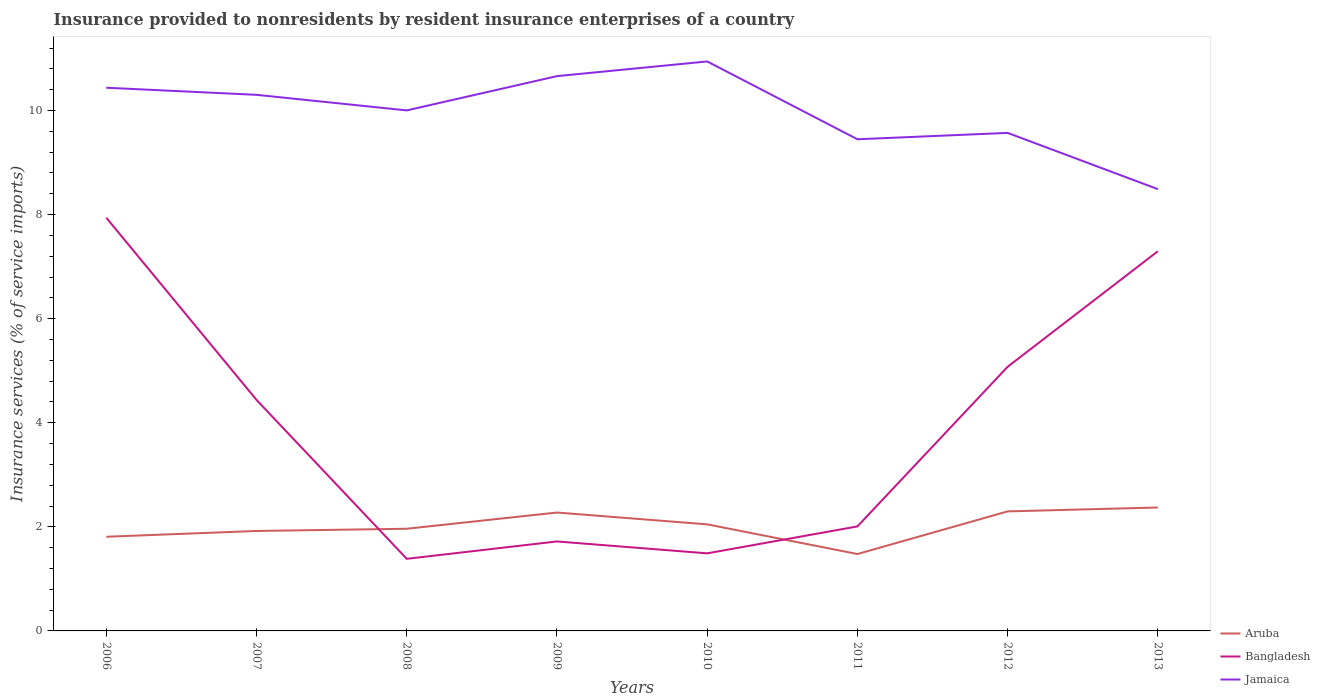Does the line corresponding to Bangladesh intersect with the line corresponding to Jamaica?
Offer a very short reply. No. Is the number of lines equal to the number of legend labels?
Offer a very short reply. Yes. Across all years, what is the maximum insurance provided to nonresidents in Jamaica?
Offer a very short reply. 8.49. In which year was the insurance provided to nonresidents in Jamaica maximum?
Offer a very short reply. 2013. What is the total insurance provided to nonresidents in Bangladesh in the graph?
Offer a very short reply. 2.43. What is the difference between the highest and the second highest insurance provided to nonresidents in Jamaica?
Your answer should be compact. 2.45. Is the insurance provided to nonresidents in Aruba strictly greater than the insurance provided to nonresidents in Jamaica over the years?
Your answer should be compact. Yes. How many years are there in the graph?
Your answer should be compact. 8. Are the values on the major ticks of Y-axis written in scientific E-notation?
Offer a very short reply. No. Does the graph contain any zero values?
Make the answer very short. No. Where does the legend appear in the graph?
Ensure brevity in your answer.  Bottom right. How are the legend labels stacked?
Your answer should be compact. Vertical. What is the title of the graph?
Provide a short and direct response. Insurance provided to nonresidents by resident insurance enterprises of a country. Does "Yemen, Rep." appear as one of the legend labels in the graph?
Your response must be concise. No. What is the label or title of the X-axis?
Your answer should be very brief. Years. What is the label or title of the Y-axis?
Your answer should be very brief. Insurance services (% of service imports). What is the Insurance services (% of service imports) in Aruba in 2006?
Keep it short and to the point. 1.81. What is the Insurance services (% of service imports) of Bangladesh in 2006?
Provide a succinct answer. 7.94. What is the Insurance services (% of service imports) of Jamaica in 2006?
Offer a very short reply. 10.44. What is the Insurance services (% of service imports) in Aruba in 2007?
Give a very brief answer. 1.92. What is the Insurance services (% of service imports) in Bangladesh in 2007?
Offer a terse response. 4.44. What is the Insurance services (% of service imports) in Jamaica in 2007?
Your answer should be compact. 10.3. What is the Insurance services (% of service imports) of Aruba in 2008?
Your answer should be very brief. 1.96. What is the Insurance services (% of service imports) of Bangladesh in 2008?
Provide a short and direct response. 1.39. What is the Insurance services (% of service imports) in Jamaica in 2008?
Keep it short and to the point. 10. What is the Insurance services (% of service imports) in Aruba in 2009?
Ensure brevity in your answer.  2.27. What is the Insurance services (% of service imports) in Bangladesh in 2009?
Your response must be concise. 1.72. What is the Insurance services (% of service imports) of Jamaica in 2009?
Provide a short and direct response. 10.66. What is the Insurance services (% of service imports) in Aruba in 2010?
Ensure brevity in your answer.  2.05. What is the Insurance services (% of service imports) of Bangladesh in 2010?
Offer a very short reply. 1.49. What is the Insurance services (% of service imports) in Jamaica in 2010?
Keep it short and to the point. 10.94. What is the Insurance services (% of service imports) of Aruba in 2011?
Offer a terse response. 1.48. What is the Insurance services (% of service imports) in Bangladesh in 2011?
Make the answer very short. 2.01. What is the Insurance services (% of service imports) of Jamaica in 2011?
Your response must be concise. 9.45. What is the Insurance services (% of service imports) of Aruba in 2012?
Give a very brief answer. 2.3. What is the Insurance services (% of service imports) in Bangladesh in 2012?
Ensure brevity in your answer.  5.08. What is the Insurance services (% of service imports) in Jamaica in 2012?
Your answer should be compact. 9.57. What is the Insurance services (% of service imports) in Aruba in 2013?
Your answer should be very brief. 2.37. What is the Insurance services (% of service imports) of Bangladesh in 2013?
Provide a succinct answer. 7.3. What is the Insurance services (% of service imports) of Jamaica in 2013?
Ensure brevity in your answer.  8.49. Across all years, what is the maximum Insurance services (% of service imports) of Aruba?
Your response must be concise. 2.37. Across all years, what is the maximum Insurance services (% of service imports) of Bangladesh?
Give a very brief answer. 7.94. Across all years, what is the maximum Insurance services (% of service imports) of Jamaica?
Your answer should be very brief. 10.94. Across all years, what is the minimum Insurance services (% of service imports) of Aruba?
Give a very brief answer. 1.48. Across all years, what is the minimum Insurance services (% of service imports) of Bangladesh?
Ensure brevity in your answer.  1.39. Across all years, what is the minimum Insurance services (% of service imports) of Jamaica?
Keep it short and to the point. 8.49. What is the total Insurance services (% of service imports) in Aruba in the graph?
Offer a terse response. 16.16. What is the total Insurance services (% of service imports) in Bangladesh in the graph?
Keep it short and to the point. 31.35. What is the total Insurance services (% of service imports) in Jamaica in the graph?
Your response must be concise. 79.85. What is the difference between the Insurance services (% of service imports) in Aruba in 2006 and that in 2007?
Keep it short and to the point. -0.11. What is the difference between the Insurance services (% of service imports) in Bangladesh in 2006 and that in 2007?
Your answer should be very brief. 3.5. What is the difference between the Insurance services (% of service imports) of Jamaica in 2006 and that in 2007?
Keep it short and to the point. 0.14. What is the difference between the Insurance services (% of service imports) in Aruba in 2006 and that in 2008?
Provide a succinct answer. -0.15. What is the difference between the Insurance services (% of service imports) of Bangladesh in 2006 and that in 2008?
Give a very brief answer. 6.55. What is the difference between the Insurance services (% of service imports) of Jamaica in 2006 and that in 2008?
Offer a terse response. 0.44. What is the difference between the Insurance services (% of service imports) of Aruba in 2006 and that in 2009?
Keep it short and to the point. -0.47. What is the difference between the Insurance services (% of service imports) in Bangladesh in 2006 and that in 2009?
Your answer should be very brief. 6.22. What is the difference between the Insurance services (% of service imports) of Jamaica in 2006 and that in 2009?
Make the answer very short. -0.22. What is the difference between the Insurance services (% of service imports) in Aruba in 2006 and that in 2010?
Offer a terse response. -0.24. What is the difference between the Insurance services (% of service imports) of Bangladesh in 2006 and that in 2010?
Make the answer very short. 6.45. What is the difference between the Insurance services (% of service imports) in Jamaica in 2006 and that in 2010?
Offer a very short reply. -0.51. What is the difference between the Insurance services (% of service imports) of Aruba in 2006 and that in 2011?
Make the answer very short. 0.33. What is the difference between the Insurance services (% of service imports) in Bangladesh in 2006 and that in 2011?
Keep it short and to the point. 5.93. What is the difference between the Insurance services (% of service imports) of Jamaica in 2006 and that in 2011?
Offer a very short reply. 0.99. What is the difference between the Insurance services (% of service imports) in Aruba in 2006 and that in 2012?
Make the answer very short. -0.49. What is the difference between the Insurance services (% of service imports) of Bangladesh in 2006 and that in 2012?
Make the answer very short. 2.86. What is the difference between the Insurance services (% of service imports) of Jamaica in 2006 and that in 2012?
Make the answer very short. 0.87. What is the difference between the Insurance services (% of service imports) in Aruba in 2006 and that in 2013?
Your answer should be very brief. -0.56. What is the difference between the Insurance services (% of service imports) in Bangladesh in 2006 and that in 2013?
Offer a very short reply. 0.64. What is the difference between the Insurance services (% of service imports) in Jamaica in 2006 and that in 2013?
Offer a terse response. 1.95. What is the difference between the Insurance services (% of service imports) of Aruba in 2007 and that in 2008?
Offer a very short reply. -0.04. What is the difference between the Insurance services (% of service imports) in Bangladesh in 2007 and that in 2008?
Ensure brevity in your answer.  3.05. What is the difference between the Insurance services (% of service imports) in Jamaica in 2007 and that in 2008?
Give a very brief answer. 0.3. What is the difference between the Insurance services (% of service imports) of Aruba in 2007 and that in 2009?
Offer a very short reply. -0.35. What is the difference between the Insurance services (% of service imports) of Bangladesh in 2007 and that in 2009?
Your answer should be compact. 2.72. What is the difference between the Insurance services (% of service imports) of Jamaica in 2007 and that in 2009?
Provide a short and direct response. -0.36. What is the difference between the Insurance services (% of service imports) of Aruba in 2007 and that in 2010?
Keep it short and to the point. -0.13. What is the difference between the Insurance services (% of service imports) in Bangladesh in 2007 and that in 2010?
Provide a short and direct response. 2.95. What is the difference between the Insurance services (% of service imports) of Jamaica in 2007 and that in 2010?
Give a very brief answer. -0.64. What is the difference between the Insurance services (% of service imports) in Aruba in 2007 and that in 2011?
Give a very brief answer. 0.44. What is the difference between the Insurance services (% of service imports) in Bangladesh in 2007 and that in 2011?
Give a very brief answer. 2.43. What is the difference between the Insurance services (% of service imports) of Jamaica in 2007 and that in 2011?
Your answer should be compact. 0.85. What is the difference between the Insurance services (% of service imports) in Aruba in 2007 and that in 2012?
Keep it short and to the point. -0.38. What is the difference between the Insurance services (% of service imports) of Bangladesh in 2007 and that in 2012?
Your answer should be compact. -0.64. What is the difference between the Insurance services (% of service imports) of Jamaica in 2007 and that in 2012?
Your answer should be very brief. 0.73. What is the difference between the Insurance services (% of service imports) of Aruba in 2007 and that in 2013?
Your answer should be compact. -0.45. What is the difference between the Insurance services (% of service imports) of Bangladesh in 2007 and that in 2013?
Make the answer very short. -2.86. What is the difference between the Insurance services (% of service imports) of Jamaica in 2007 and that in 2013?
Keep it short and to the point. 1.81. What is the difference between the Insurance services (% of service imports) of Aruba in 2008 and that in 2009?
Make the answer very short. -0.31. What is the difference between the Insurance services (% of service imports) in Bangladesh in 2008 and that in 2009?
Your answer should be very brief. -0.33. What is the difference between the Insurance services (% of service imports) in Jamaica in 2008 and that in 2009?
Provide a short and direct response. -0.66. What is the difference between the Insurance services (% of service imports) of Aruba in 2008 and that in 2010?
Your answer should be compact. -0.08. What is the difference between the Insurance services (% of service imports) of Bangladesh in 2008 and that in 2010?
Offer a very short reply. -0.1. What is the difference between the Insurance services (% of service imports) of Jamaica in 2008 and that in 2010?
Provide a short and direct response. -0.94. What is the difference between the Insurance services (% of service imports) of Aruba in 2008 and that in 2011?
Provide a short and direct response. 0.49. What is the difference between the Insurance services (% of service imports) in Bangladesh in 2008 and that in 2011?
Offer a very short reply. -0.62. What is the difference between the Insurance services (% of service imports) in Jamaica in 2008 and that in 2011?
Give a very brief answer. 0.55. What is the difference between the Insurance services (% of service imports) of Aruba in 2008 and that in 2012?
Give a very brief answer. -0.33. What is the difference between the Insurance services (% of service imports) of Bangladesh in 2008 and that in 2012?
Provide a short and direct response. -3.69. What is the difference between the Insurance services (% of service imports) of Jamaica in 2008 and that in 2012?
Give a very brief answer. 0.43. What is the difference between the Insurance services (% of service imports) of Aruba in 2008 and that in 2013?
Ensure brevity in your answer.  -0.41. What is the difference between the Insurance services (% of service imports) of Bangladesh in 2008 and that in 2013?
Your answer should be compact. -5.91. What is the difference between the Insurance services (% of service imports) in Jamaica in 2008 and that in 2013?
Provide a short and direct response. 1.51. What is the difference between the Insurance services (% of service imports) in Aruba in 2009 and that in 2010?
Make the answer very short. 0.23. What is the difference between the Insurance services (% of service imports) in Bangladesh in 2009 and that in 2010?
Give a very brief answer. 0.23. What is the difference between the Insurance services (% of service imports) of Jamaica in 2009 and that in 2010?
Your answer should be very brief. -0.28. What is the difference between the Insurance services (% of service imports) in Aruba in 2009 and that in 2011?
Provide a succinct answer. 0.8. What is the difference between the Insurance services (% of service imports) in Bangladesh in 2009 and that in 2011?
Your answer should be compact. -0.29. What is the difference between the Insurance services (% of service imports) of Jamaica in 2009 and that in 2011?
Provide a succinct answer. 1.21. What is the difference between the Insurance services (% of service imports) in Aruba in 2009 and that in 2012?
Keep it short and to the point. -0.02. What is the difference between the Insurance services (% of service imports) in Bangladesh in 2009 and that in 2012?
Your answer should be compact. -3.36. What is the difference between the Insurance services (% of service imports) in Jamaica in 2009 and that in 2012?
Provide a short and direct response. 1.09. What is the difference between the Insurance services (% of service imports) of Aruba in 2009 and that in 2013?
Ensure brevity in your answer.  -0.1. What is the difference between the Insurance services (% of service imports) in Bangladesh in 2009 and that in 2013?
Provide a succinct answer. -5.58. What is the difference between the Insurance services (% of service imports) in Jamaica in 2009 and that in 2013?
Give a very brief answer. 2.17. What is the difference between the Insurance services (% of service imports) in Aruba in 2010 and that in 2011?
Give a very brief answer. 0.57. What is the difference between the Insurance services (% of service imports) in Bangladesh in 2010 and that in 2011?
Your answer should be compact. -0.52. What is the difference between the Insurance services (% of service imports) in Jamaica in 2010 and that in 2011?
Offer a very short reply. 1.5. What is the difference between the Insurance services (% of service imports) of Aruba in 2010 and that in 2012?
Offer a terse response. -0.25. What is the difference between the Insurance services (% of service imports) in Bangladesh in 2010 and that in 2012?
Offer a terse response. -3.59. What is the difference between the Insurance services (% of service imports) in Jamaica in 2010 and that in 2012?
Ensure brevity in your answer.  1.37. What is the difference between the Insurance services (% of service imports) in Aruba in 2010 and that in 2013?
Your answer should be very brief. -0.32. What is the difference between the Insurance services (% of service imports) in Bangladesh in 2010 and that in 2013?
Provide a short and direct response. -5.81. What is the difference between the Insurance services (% of service imports) in Jamaica in 2010 and that in 2013?
Offer a very short reply. 2.45. What is the difference between the Insurance services (% of service imports) in Aruba in 2011 and that in 2012?
Your answer should be very brief. -0.82. What is the difference between the Insurance services (% of service imports) in Bangladesh in 2011 and that in 2012?
Ensure brevity in your answer.  -3.07. What is the difference between the Insurance services (% of service imports) in Jamaica in 2011 and that in 2012?
Ensure brevity in your answer.  -0.12. What is the difference between the Insurance services (% of service imports) in Aruba in 2011 and that in 2013?
Provide a succinct answer. -0.89. What is the difference between the Insurance services (% of service imports) of Bangladesh in 2011 and that in 2013?
Make the answer very short. -5.29. What is the difference between the Insurance services (% of service imports) in Jamaica in 2011 and that in 2013?
Provide a short and direct response. 0.96. What is the difference between the Insurance services (% of service imports) in Aruba in 2012 and that in 2013?
Your response must be concise. -0.08. What is the difference between the Insurance services (% of service imports) in Bangladesh in 2012 and that in 2013?
Provide a succinct answer. -2.22. What is the difference between the Insurance services (% of service imports) in Jamaica in 2012 and that in 2013?
Provide a short and direct response. 1.08. What is the difference between the Insurance services (% of service imports) of Aruba in 2006 and the Insurance services (% of service imports) of Bangladesh in 2007?
Make the answer very short. -2.63. What is the difference between the Insurance services (% of service imports) of Aruba in 2006 and the Insurance services (% of service imports) of Jamaica in 2007?
Make the answer very short. -8.49. What is the difference between the Insurance services (% of service imports) in Bangladesh in 2006 and the Insurance services (% of service imports) in Jamaica in 2007?
Give a very brief answer. -2.36. What is the difference between the Insurance services (% of service imports) in Aruba in 2006 and the Insurance services (% of service imports) in Bangladesh in 2008?
Keep it short and to the point. 0.42. What is the difference between the Insurance services (% of service imports) in Aruba in 2006 and the Insurance services (% of service imports) in Jamaica in 2008?
Give a very brief answer. -8.19. What is the difference between the Insurance services (% of service imports) in Bangladesh in 2006 and the Insurance services (% of service imports) in Jamaica in 2008?
Provide a short and direct response. -2.06. What is the difference between the Insurance services (% of service imports) in Aruba in 2006 and the Insurance services (% of service imports) in Bangladesh in 2009?
Give a very brief answer. 0.09. What is the difference between the Insurance services (% of service imports) of Aruba in 2006 and the Insurance services (% of service imports) of Jamaica in 2009?
Keep it short and to the point. -8.85. What is the difference between the Insurance services (% of service imports) of Bangladesh in 2006 and the Insurance services (% of service imports) of Jamaica in 2009?
Give a very brief answer. -2.72. What is the difference between the Insurance services (% of service imports) in Aruba in 2006 and the Insurance services (% of service imports) in Bangladesh in 2010?
Ensure brevity in your answer.  0.32. What is the difference between the Insurance services (% of service imports) of Aruba in 2006 and the Insurance services (% of service imports) of Jamaica in 2010?
Make the answer very short. -9.13. What is the difference between the Insurance services (% of service imports) of Bangladesh in 2006 and the Insurance services (% of service imports) of Jamaica in 2010?
Keep it short and to the point. -3. What is the difference between the Insurance services (% of service imports) of Aruba in 2006 and the Insurance services (% of service imports) of Bangladesh in 2011?
Give a very brief answer. -0.2. What is the difference between the Insurance services (% of service imports) of Aruba in 2006 and the Insurance services (% of service imports) of Jamaica in 2011?
Ensure brevity in your answer.  -7.64. What is the difference between the Insurance services (% of service imports) in Bangladesh in 2006 and the Insurance services (% of service imports) in Jamaica in 2011?
Make the answer very short. -1.51. What is the difference between the Insurance services (% of service imports) of Aruba in 2006 and the Insurance services (% of service imports) of Bangladesh in 2012?
Your answer should be compact. -3.27. What is the difference between the Insurance services (% of service imports) in Aruba in 2006 and the Insurance services (% of service imports) in Jamaica in 2012?
Ensure brevity in your answer.  -7.76. What is the difference between the Insurance services (% of service imports) of Bangladesh in 2006 and the Insurance services (% of service imports) of Jamaica in 2012?
Ensure brevity in your answer.  -1.63. What is the difference between the Insurance services (% of service imports) of Aruba in 2006 and the Insurance services (% of service imports) of Bangladesh in 2013?
Your answer should be very brief. -5.49. What is the difference between the Insurance services (% of service imports) of Aruba in 2006 and the Insurance services (% of service imports) of Jamaica in 2013?
Provide a short and direct response. -6.68. What is the difference between the Insurance services (% of service imports) of Bangladesh in 2006 and the Insurance services (% of service imports) of Jamaica in 2013?
Your response must be concise. -0.55. What is the difference between the Insurance services (% of service imports) in Aruba in 2007 and the Insurance services (% of service imports) in Bangladesh in 2008?
Offer a terse response. 0.53. What is the difference between the Insurance services (% of service imports) of Aruba in 2007 and the Insurance services (% of service imports) of Jamaica in 2008?
Your answer should be compact. -8.08. What is the difference between the Insurance services (% of service imports) of Bangladesh in 2007 and the Insurance services (% of service imports) of Jamaica in 2008?
Give a very brief answer. -5.56. What is the difference between the Insurance services (% of service imports) of Aruba in 2007 and the Insurance services (% of service imports) of Bangladesh in 2009?
Your answer should be very brief. 0.2. What is the difference between the Insurance services (% of service imports) of Aruba in 2007 and the Insurance services (% of service imports) of Jamaica in 2009?
Provide a short and direct response. -8.74. What is the difference between the Insurance services (% of service imports) of Bangladesh in 2007 and the Insurance services (% of service imports) of Jamaica in 2009?
Offer a very short reply. -6.22. What is the difference between the Insurance services (% of service imports) of Aruba in 2007 and the Insurance services (% of service imports) of Bangladesh in 2010?
Provide a succinct answer. 0.43. What is the difference between the Insurance services (% of service imports) of Aruba in 2007 and the Insurance services (% of service imports) of Jamaica in 2010?
Ensure brevity in your answer.  -9.02. What is the difference between the Insurance services (% of service imports) of Bangladesh in 2007 and the Insurance services (% of service imports) of Jamaica in 2010?
Your answer should be very brief. -6.5. What is the difference between the Insurance services (% of service imports) in Aruba in 2007 and the Insurance services (% of service imports) in Bangladesh in 2011?
Offer a terse response. -0.09. What is the difference between the Insurance services (% of service imports) in Aruba in 2007 and the Insurance services (% of service imports) in Jamaica in 2011?
Keep it short and to the point. -7.53. What is the difference between the Insurance services (% of service imports) of Bangladesh in 2007 and the Insurance services (% of service imports) of Jamaica in 2011?
Your response must be concise. -5.01. What is the difference between the Insurance services (% of service imports) of Aruba in 2007 and the Insurance services (% of service imports) of Bangladesh in 2012?
Ensure brevity in your answer.  -3.16. What is the difference between the Insurance services (% of service imports) in Aruba in 2007 and the Insurance services (% of service imports) in Jamaica in 2012?
Your answer should be compact. -7.65. What is the difference between the Insurance services (% of service imports) of Bangladesh in 2007 and the Insurance services (% of service imports) of Jamaica in 2012?
Provide a succinct answer. -5.13. What is the difference between the Insurance services (% of service imports) in Aruba in 2007 and the Insurance services (% of service imports) in Bangladesh in 2013?
Provide a short and direct response. -5.38. What is the difference between the Insurance services (% of service imports) of Aruba in 2007 and the Insurance services (% of service imports) of Jamaica in 2013?
Your answer should be very brief. -6.57. What is the difference between the Insurance services (% of service imports) in Bangladesh in 2007 and the Insurance services (% of service imports) in Jamaica in 2013?
Provide a short and direct response. -4.05. What is the difference between the Insurance services (% of service imports) in Aruba in 2008 and the Insurance services (% of service imports) in Bangladesh in 2009?
Make the answer very short. 0.24. What is the difference between the Insurance services (% of service imports) in Aruba in 2008 and the Insurance services (% of service imports) in Jamaica in 2009?
Ensure brevity in your answer.  -8.7. What is the difference between the Insurance services (% of service imports) in Bangladesh in 2008 and the Insurance services (% of service imports) in Jamaica in 2009?
Provide a succinct answer. -9.27. What is the difference between the Insurance services (% of service imports) in Aruba in 2008 and the Insurance services (% of service imports) in Bangladesh in 2010?
Ensure brevity in your answer.  0.47. What is the difference between the Insurance services (% of service imports) of Aruba in 2008 and the Insurance services (% of service imports) of Jamaica in 2010?
Give a very brief answer. -8.98. What is the difference between the Insurance services (% of service imports) of Bangladesh in 2008 and the Insurance services (% of service imports) of Jamaica in 2010?
Offer a terse response. -9.56. What is the difference between the Insurance services (% of service imports) in Aruba in 2008 and the Insurance services (% of service imports) in Bangladesh in 2011?
Your answer should be very brief. -0.04. What is the difference between the Insurance services (% of service imports) of Aruba in 2008 and the Insurance services (% of service imports) of Jamaica in 2011?
Your answer should be very brief. -7.48. What is the difference between the Insurance services (% of service imports) of Bangladesh in 2008 and the Insurance services (% of service imports) of Jamaica in 2011?
Ensure brevity in your answer.  -8.06. What is the difference between the Insurance services (% of service imports) of Aruba in 2008 and the Insurance services (% of service imports) of Bangladesh in 2012?
Keep it short and to the point. -3.11. What is the difference between the Insurance services (% of service imports) of Aruba in 2008 and the Insurance services (% of service imports) of Jamaica in 2012?
Provide a short and direct response. -7.61. What is the difference between the Insurance services (% of service imports) of Bangladesh in 2008 and the Insurance services (% of service imports) of Jamaica in 2012?
Give a very brief answer. -8.18. What is the difference between the Insurance services (% of service imports) of Aruba in 2008 and the Insurance services (% of service imports) of Bangladesh in 2013?
Offer a terse response. -5.33. What is the difference between the Insurance services (% of service imports) in Aruba in 2008 and the Insurance services (% of service imports) in Jamaica in 2013?
Give a very brief answer. -6.52. What is the difference between the Insurance services (% of service imports) in Bangladesh in 2008 and the Insurance services (% of service imports) in Jamaica in 2013?
Offer a terse response. -7.1. What is the difference between the Insurance services (% of service imports) of Aruba in 2009 and the Insurance services (% of service imports) of Bangladesh in 2010?
Give a very brief answer. 0.78. What is the difference between the Insurance services (% of service imports) of Aruba in 2009 and the Insurance services (% of service imports) of Jamaica in 2010?
Keep it short and to the point. -8.67. What is the difference between the Insurance services (% of service imports) in Bangladesh in 2009 and the Insurance services (% of service imports) in Jamaica in 2010?
Your answer should be compact. -9.22. What is the difference between the Insurance services (% of service imports) of Aruba in 2009 and the Insurance services (% of service imports) of Bangladesh in 2011?
Your answer should be compact. 0.27. What is the difference between the Insurance services (% of service imports) in Aruba in 2009 and the Insurance services (% of service imports) in Jamaica in 2011?
Your answer should be compact. -7.17. What is the difference between the Insurance services (% of service imports) in Bangladesh in 2009 and the Insurance services (% of service imports) in Jamaica in 2011?
Offer a terse response. -7.73. What is the difference between the Insurance services (% of service imports) in Aruba in 2009 and the Insurance services (% of service imports) in Bangladesh in 2012?
Your response must be concise. -2.8. What is the difference between the Insurance services (% of service imports) of Aruba in 2009 and the Insurance services (% of service imports) of Jamaica in 2012?
Offer a very short reply. -7.29. What is the difference between the Insurance services (% of service imports) in Bangladesh in 2009 and the Insurance services (% of service imports) in Jamaica in 2012?
Your response must be concise. -7.85. What is the difference between the Insurance services (% of service imports) of Aruba in 2009 and the Insurance services (% of service imports) of Bangladesh in 2013?
Offer a very short reply. -5.02. What is the difference between the Insurance services (% of service imports) in Aruba in 2009 and the Insurance services (% of service imports) in Jamaica in 2013?
Your answer should be compact. -6.21. What is the difference between the Insurance services (% of service imports) in Bangladesh in 2009 and the Insurance services (% of service imports) in Jamaica in 2013?
Offer a very short reply. -6.77. What is the difference between the Insurance services (% of service imports) of Aruba in 2010 and the Insurance services (% of service imports) of Bangladesh in 2011?
Your answer should be compact. 0.04. What is the difference between the Insurance services (% of service imports) of Aruba in 2010 and the Insurance services (% of service imports) of Jamaica in 2011?
Keep it short and to the point. -7.4. What is the difference between the Insurance services (% of service imports) of Bangladesh in 2010 and the Insurance services (% of service imports) of Jamaica in 2011?
Provide a short and direct response. -7.96. What is the difference between the Insurance services (% of service imports) of Aruba in 2010 and the Insurance services (% of service imports) of Bangladesh in 2012?
Provide a short and direct response. -3.03. What is the difference between the Insurance services (% of service imports) in Aruba in 2010 and the Insurance services (% of service imports) in Jamaica in 2012?
Keep it short and to the point. -7.52. What is the difference between the Insurance services (% of service imports) in Bangladesh in 2010 and the Insurance services (% of service imports) in Jamaica in 2012?
Your answer should be compact. -8.08. What is the difference between the Insurance services (% of service imports) in Aruba in 2010 and the Insurance services (% of service imports) in Bangladesh in 2013?
Your answer should be compact. -5.25. What is the difference between the Insurance services (% of service imports) in Aruba in 2010 and the Insurance services (% of service imports) in Jamaica in 2013?
Your response must be concise. -6.44. What is the difference between the Insurance services (% of service imports) of Bangladesh in 2010 and the Insurance services (% of service imports) of Jamaica in 2013?
Give a very brief answer. -7. What is the difference between the Insurance services (% of service imports) of Aruba in 2011 and the Insurance services (% of service imports) of Bangladesh in 2012?
Provide a succinct answer. -3.6. What is the difference between the Insurance services (% of service imports) in Aruba in 2011 and the Insurance services (% of service imports) in Jamaica in 2012?
Offer a very short reply. -8.09. What is the difference between the Insurance services (% of service imports) in Bangladesh in 2011 and the Insurance services (% of service imports) in Jamaica in 2012?
Offer a terse response. -7.56. What is the difference between the Insurance services (% of service imports) of Aruba in 2011 and the Insurance services (% of service imports) of Bangladesh in 2013?
Your response must be concise. -5.82. What is the difference between the Insurance services (% of service imports) of Aruba in 2011 and the Insurance services (% of service imports) of Jamaica in 2013?
Provide a succinct answer. -7.01. What is the difference between the Insurance services (% of service imports) of Bangladesh in 2011 and the Insurance services (% of service imports) of Jamaica in 2013?
Your answer should be compact. -6.48. What is the difference between the Insurance services (% of service imports) of Aruba in 2012 and the Insurance services (% of service imports) of Bangladesh in 2013?
Provide a succinct answer. -5. What is the difference between the Insurance services (% of service imports) of Aruba in 2012 and the Insurance services (% of service imports) of Jamaica in 2013?
Make the answer very short. -6.19. What is the difference between the Insurance services (% of service imports) of Bangladesh in 2012 and the Insurance services (% of service imports) of Jamaica in 2013?
Make the answer very short. -3.41. What is the average Insurance services (% of service imports) in Aruba per year?
Ensure brevity in your answer.  2.02. What is the average Insurance services (% of service imports) of Bangladesh per year?
Provide a short and direct response. 3.92. What is the average Insurance services (% of service imports) in Jamaica per year?
Your response must be concise. 9.98. In the year 2006, what is the difference between the Insurance services (% of service imports) in Aruba and Insurance services (% of service imports) in Bangladesh?
Your answer should be compact. -6.13. In the year 2006, what is the difference between the Insurance services (% of service imports) of Aruba and Insurance services (% of service imports) of Jamaica?
Give a very brief answer. -8.63. In the year 2006, what is the difference between the Insurance services (% of service imports) of Bangladesh and Insurance services (% of service imports) of Jamaica?
Offer a terse response. -2.5. In the year 2007, what is the difference between the Insurance services (% of service imports) in Aruba and Insurance services (% of service imports) in Bangladesh?
Offer a terse response. -2.52. In the year 2007, what is the difference between the Insurance services (% of service imports) in Aruba and Insurance services (% of service imports) in Jamaica?
Offer a terse response. -8.38. In the year 2007, what is the difference between the Insurance services (% of service imports) in Bangladesh and Insurance services (% of service imports) in Jamaica?
Offer a terse response. -5.86. In the year 2008, what is the difference between the Insurance services (% of service imports) of Aruba and Insurance services (% of service imports) of Bangladesh?
Offer a terse response. 0.58. In the year 2008, what is the difference between the Insurance services (% of service imports) of Aruba and Insurance services (% of service imports) of Jamaica?
Offer a very short reply. -8.04. In the year 2008, what is the difference between the Insurance services (% of service imports) of Bangladesh and Insurance services (% of service imports) of Jamaica?
Offer a terse response. -8.62. In the year 2009, what is the difference between the Insurance services (% of service imports) of Aruba and Insurance services (% of service imports) of Bangladesh?
Offer a very short reply. 0.56. In the year 2009, what is the difference between the Insurance services (% of service imports) in Aruba and Insurance services (% of service imports) in Jamaica?
Your response must be concise. -8.39. In the year 2009, what is the difference between the Insurance services (% of service imports) in Bangladesh and Insurance services (% of service imports) in Jamaica?
Provide a short and direct response. -8.94. In the year 2010, what is the difference between the Insurance services (% of service imports) in Aruba and Insurance services (% of service imports) in Bangladesh?
Your answer should be very brief. 0.56. In the year 2010, what is the difference between the Insurance services (% of service imports) of Aruba and Insurance services (% of service imports) of Jamaica?
Give a very brief answer. -8.89. In the year 2010, what is the difference between the Insurance services (% of service imports) of Bangladesh and Insurance services (% of service imports) of Jamaica?
Give a very brief answer. -9.45. In the year 2011, what is the difference between the Insurance services (% of service imports) in Aruba and Insurance services (% of service imports) in Bangladesh?
Your answer should be compact. -0.53. In the year 2011, what is the difference between the Insurance services (% of service imports) of Aruba and Insurance services (% of service imports) of Jamaica?
Make the answer very short. -7.97. In the year 2011, what is the difference between the Insurance services (% of service imports) in Bangladesh and Insurance services (% of service imports) in Jamaica?
Your answer should be compact. -7.44. In the year 2012, what is the difference between the Insurance services (% of service imports) of Aruba and Insurance services (% of service imports) of Bangladesh?
Give a very brief answer. -2.78. In the year 2012, what is the difference between the Insurance services (% of service imports) of Aruba and Insurance services (% of service imports) of Jamaica?
Your answer should be compact. -7.27. In the year 2012, what is the difference between the Insurance services (% of service imports) in Bangladesh and Insurance services (% of service imports) in Jamaica?
Offer a terse response. -4.49. In the year 2013, what is the difference between the Insurance services (% of service imports) in Aruba and Insurance services (% of service imports) in Bangladesh?
Give a very brief answer. -4.92. In the year 2013, what is the difference between the Insurance services (% of service imports) in Aruba and Insurance services (% of service imports) in Jamaica?
Provide a short and direct response. -6.12. In the year 2013, what is the difference between the Insurance services (% of service imports) in Bangladesh and Insurance services (% of service imports) in Jamaica?
Offer a terse response. -1.19. What is the ratio of the Insurance services (% of service imports) in Aruba in 2006 to that in 2007?
Provide a succinct answer. 0.94. What is the ratio of the Insurance services (% of service imports) in Bangladesh in 2006 to that in 2007?
Your response must be concise. 1.79. What is the ratio of the Insurance services (% of service imports) in Jamaica in 2006 to that in 2007?
Provide a succinct answer. 1.01. What is the ratio of the Insurance services (% of service imports) in Aruba in 2006 to that in 2008?
Your answer should be very brief. 0.92. What is the ratio of the Insurance services (% of service imports) of Bangladesh in 2006 to that in 2008?
Your answer should be very brief. 5.73. What is the ratio of the Insurance services (% of service imports) of Jamaica in 2006 to that in 2008?
Your response must be concise. 1.04. What is the ratio of the Insurance services (% of service imports) of Aruba in 2006 to that in 2009?
Offer a terse response. 0.8. What is the ratio of the Insurance services (% of service imports) in Bangladesh in 2006 to that in 2009?
Give a very brief answer. 4.62. What is the ratio of the Insurance services (% of service imports) of Jamaica in 2006 to that in 2009?
Your answer should be very brief. 0.98. What is the ratio of the Insurance services (% of service imports) of Aruba in 2006 to that in 2010?
Provide a short and direct response. 0.88. What is the ratio of the Insurance services (% of service imports) in Bangladesh in 2006 to that in 2010?
Provide a short and direct response. 5.33. What is the ratio of the Insurance services (% of service imports) in Jamaica in 2006 to that in 2010?
Make the answer very short. 0.95. What is the ratio of the Insurance services (% of service imports) in Aruba in 2006 to that in 2011?
Provide a succinct answer. 1.22. What is the ratio of the Insurance services (% of service imports) of Bangladesh in 2006 to that in 2011?
Keep it short and to the point. 3.95. What is the ratio of the Insurance services (% of service imports) of Jamaica in 2006 to that in 2011?
Give a very brief answer. 1.1. What is the ratio of the Insurance services (% of service imports) of Aruba in 2006 to that in 2012?
Offer a terse response. 0.79. What is the ratio of the Insurance services (% of service imports) of Bangladesh in 2006 to that in 2012?
Offer a terse response. 1.56. What is the ratio of the Insurance services (% of service imports) of Jamaica in 2006 to that in 2012?
Provide a succinct answer. 1.09. What is the ratio of the Insurance services (% of service imports) of Aruba in 2006 to that in 2013?
Offer a terse response. 0.76. What is the ratio of the Insurance services (% of service imports) of Bangladesh in 2006 to that in 2013?
Provide a short and direct response. 1.09. What is the ratio of the Insurance services (% of service imports) of Jamaica in 2006 to that in 2013?
Offer a terse response. 1.23. What is the ratio of the Insurance services (% of service imports) in Aruba in 2007 to that in 2008?
Make the answer very short. 0.98. What is the ratio of the Insurance services (% of service imports) of Bangladesh in 2007 to that in 2008?
Offer a very short reply. 3.2. What is the ratio of the Insurance services (% of service imports) of Jamaica in 2007 to that in 2008?
Give a very brief answer. 1.03. What is the ratio of the Insurance services (% of service imports) in Aruba in 2007 to that in 2009?
Ensure brevity in your answer.  0.84. What is the ratio of the Insurance services (% of service imports) of Bangladesh in 2007 to that in 2009?
Provide a short and direct response. 2.58. What is the ratio of the Insurance services (% of service imports) in Jamaica in 2007 to that in 2009?
Your answer should be very brief. 0.97. What is the ratio of the Insurance services (% of service imports) of Aruba in 2007 to that in 2010?
Make the answer very short. 0.94. What is the ratio of the Insurance services (% of service imports) of Bangladesh in 2007 to that in 2010?
Give a very brief answer. 2.98. What is the ratio of the Insurance services (% of service imports) in Jamaica in 2007 to that in 2010?
Give a very brief answer. 0.94. What is the ratio of the Insurance services (% of service imports) of Aruba in 2007 to that in 2011?
Keep it short and to the point. 1.3. What is the ratio of the Insurance services (% of service imports) in Bangladesh in 2007 to that in 2011?
Keep it short and to the point. 2.21. What is the ratio of the Insurance services (% of service imports) in Jamaica in 2007 to that in 2011?
Offer a terse response. 1.09. What is the ratio of the Insurance services (% of service imports) of Aruba in 2007 to that in 2012?
Provide a succinct answer. 0.84. What is the ratio of the Insurance services (% of service imports) of Bangladesh in 2007 to that in 2012?
Your answer should be compact. 0.87. What is the ratio of the Insurance services (% of service imports) in Jamaica in 2007 to that in 2012?
Ensure brevity in your answer.  1.08. What is the ratio of the Insurance services (% of service imports) in Aruba in 2007 to that in 2013?
Offer a very short reply. 0.81. What is the ratio of the Insurance services (% of service imports) in Bangladesh in 2007 to that in 2013?
Your answer should be very brief. 0.61. What is the ratio of the Insurance services (% of service imports) of Jamaica in 2007 to that in 2013?
Offer a terse response. 1.21. What is the ratio of the Insurance services (% of service imports) of Aruba in 2008 to that in 2009?
Offer a very short reply. 0.86. What is the ratio of the Insurance services (% of service imports) in Bangladesh in 2008 to that in 2009?
Keep it short and to the point. 0.81. What is the ratio of the Insurance services (% of service imports) in Jamaica in 2008 to that in 2009?
Keep it short and to the point. 0.94. What is the ratio of the Insurance services (% of service imports) in Aruba in 2008 to that in 2010?
Offer a terse response. 0.96. What is the ratio of the Insurance services (% of service imports) of Bangladesh in 2008 to that in 2010?
Your answer should be very brief. 0.93. What is the ratio of the Insurance services (% of service imports) of Jamaica in 2008 to that in 2010?
Give a very brief answer. 0.91. What is the ratio of the Insurance services (% of service imports) in Aruba in 2008 to that in 2011?
Your answer should be very brief. 1.33. What is the ratio of the Insurance services (% of service imports) in Bangladesh in 2008 to that in 2011?
Offer a very short reply. 0.69. What is the ratio of the Insurance services (% of service imports) in Jamaica in 2008 to that in 2011?
Your answer should be compact. 1.06. What is the ratio of the Insurance services (% of service imports) in Aruba in 2008 to that in 2012?
Make the answer very short. 0.85. What is the ratio of the Insurance services (% of service imports) of Bangladesh in 2008 to that in 2012?
Keep it short and to the point. 0.27. What is the ratio of the Insurance services (% of service imports) of Jamaica in 2008 to that in 2012?
Your answer should be compact. 1.05. What is the ratio of the Insurance services (% of service imports) in Aruba in 2008 to that in 2013?
Offer a terse response. 0.83. What is the ratio of the Insurance services (% of service imports) in Bangladesh in 2008 to that in 2013?
Make the answer very short. 0.19. What is the ratio of the Insurance services (% of service imports) of Jamaica in 2008 to that in 2013?
Your response must be concise. 1.18. What is the ratio of the Insurance services (% of service imports) of Aruba in 2009 to that in 2010?
Give a very brief answer. 1.11. What is the ratio of the Insurance services (% of service imports) of Bangladesh in 2009 to that in 2010?
Your answer should be compact. 1.15. What is the ratio of the Insurance services (% of service imports) in Jamaica in 2009 to that in 2010?
Your answer should be very brief. 0.97. What is the ratio of the Insurance services (% of service imports) in Aruba in 2009 to that in 2011?
Give a very brief answer. 1.54. What is the ratio of the Insurance services (% of service imports) in Bangladesh in 2009 to that in 2011?
Keep it short and to the point. 0.86. What is the ratio of the Insurance services (% of service imports) in Jamaica in 2009 to that in 2011?
Your response must be concise. 1.13. What is the ratio of the Insurance services (% of service imports) in Aruba in 2009 to that in 2012?
Provide a succinct answer. 0.99. What is the ratio of the Insurance services (% of service imports) in Bangladesh in 2009 to that in 2012?
Ensure brevity in your answer.  0.34. What is the ratio of the Insurance services (% of service imports) of Jamaica in 2009 to that in 2012?
Offer a terse response. 1.11. What is the ratio of the Insurance services (% of service imports) of Aruba in 2009 to that in 2013?
Your answer should be very brief. 0.96. What is the ratio of the Insurance services (% of service imports) of Bangladesh in 2009 to that in 2013?
Offer a very short reply. 0.24. What is the ratio of the Insurance services (% of service imports) in Jamaica in 2009 to that in 2013?
Offer a terse response. 1.26. What is the ratio of the Insurance services (% of service imports) of Aruba in 2010 to that in 2011?
Offer a very short reply. 1.39. What is the ratio of the Insurance services (% of service imports) in Bangladesh in 2010 to that in 2011?
Ensure brevity in your answer.  0.74. What is the ratio of the Insurance services (% of service imports) in Jamaica in 2010 to that in 2011?
Keep it short and to the point. 1.16. What is the ratio of the Insurance services (% of service imports) in Aruba in 2010 to that in 2012?
Offer a very short reply. 0.89. What is the ratio of the Insurance services (% of service imports) of Bangladesh in 2010 to that in 2012?
Offer a terse response. 0.29. What is the ratio of the Insurance services (% of service imports) of Jamaica in 2010 to that in 2012?
Provide a succinct answer. 1.14. What is the ratio of the Insurance services (% of service imports) in Aruba in 2010 to that in 2013?
Offer a terse response. 0.86. What is the ratio of the Insurance services (% of service imports) of Bangladesh in 2010 to that in 2013?
Your response must be concise. 0.2. What is the ratio of the Insurance services (% of service imports) of Jamaica in 2010 to that in 2013?
Provide a succinct answer. 1.29. What is the ratio of the Insurance services (% of service imports) of Aruba in 2011 to that in 2012?
Provide a short and direct response. 0.64. What is the ratio of the Insurance services (% of service imports) in Bangladesh in 2011 to that in 2012?
Offer a terse response. 0.4. What is the ratio of the Insurance services (% of service imports) in Jamaica in 2011 to that in 2012?
Give a very brief answer. 0.99. What is the ratio of the Insurance services (% of service imports) of Aruba in 2011 to that in 2013?
Make the answer very short. 0.62. What is the ratio of the Insurance services (% of service imports) of Bangladesh in 2011 to that in 2013?
Provide a short and direct response. 0.28. What is the ratio of the Insurance services (% of service imports) in Jamaica in 2011 to that in 2013?
Your answer should be compact. 1.11. What is the ratio of the Insurance services (% of service imports) of Aruba in 2012 to that in 2013?
Provide a succinct answer. 0.97. What is the ratio of the Insurance services (% of service imports) of Bangladesh in 2012 to that in 2013?
Your answer should be compact. 0.7. What is the ratio of the Insurance services (% of service imports) in Jamaica in 2012 to that in 2013?
Keep it short and to the point. 1.13. What is the difference between the highest and the second highest Insurance services (% of service imports) in Aruba?
Your answer should be compact. 0.08. What is the difference between the highest and the second highest Insurance services (% of service imports) of Bangladesh?
Keep it short and to the point. 0.64. What is the difference between the highest and the second highest Insurance services (% of service imports) in Jamaica?
Give a very brief answer. 0.28. What is the difference between the highest and the lowest Insurance services (% of service imports) in Aruba?
Your response must be concise. 0.89. What is the difference between the highest and the lowest Insurance services (% of service imports) in Bangladesh?
Offer a terse response. 6.55. What is the difference between the highest and the lowest Insurance services (% of service imports) of Jamaica?
Offer a very short reply. 2.45. 